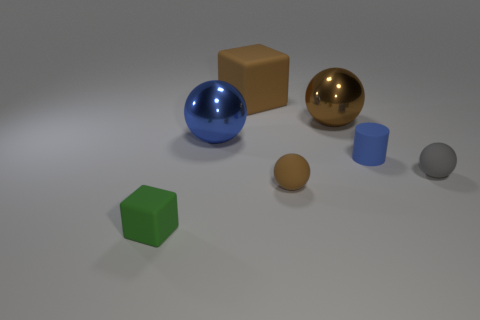Add 2 small brown balls. How many objects exist? 9 Subtract all cubes. How many objects are left? 5 Add 7 small gray balls. How many small gray balls exist? 8 Subtract 1 blue balls. How many objects are left? 6 Subtract all matte balls. Subtract all tiny gray matte spheres. How many objects are left? 4 Add 3 balls. How many balls are left? 7 